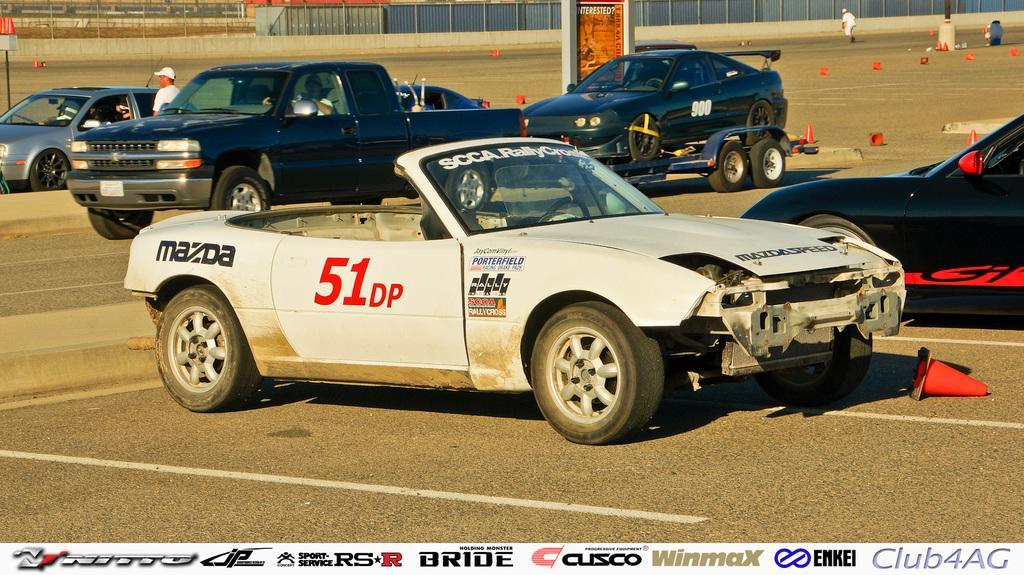Can you describe this image briefly? In this image there is a road. There are vehicles moving on the road. There are people. There are red color objects on the road. There is a net fencing in the background. There is a wall. 